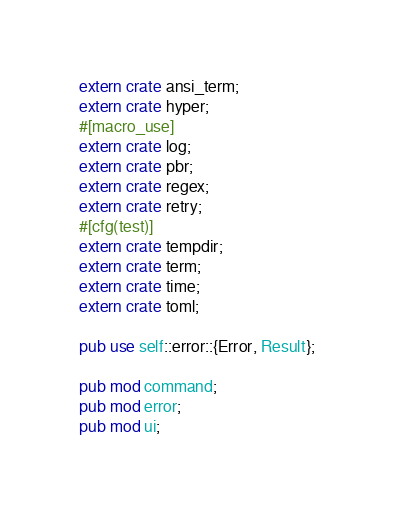<code> <loc_0><loc_0><loc_500><loc_500><_Rust_>extern crate ansi_term;
extern crate hyper;
#[macro_use]
extern crate log;
extern crate pbr;
extern crate regex;
extern crate retry;
#[cfg(test)]
extern crate tempdir;
extern crate term;
extern crate time;
extern crate toml;

pub use self::error::{Error, Result};

pub mod command;
pub mod error;
pub mod ui;
</code> 